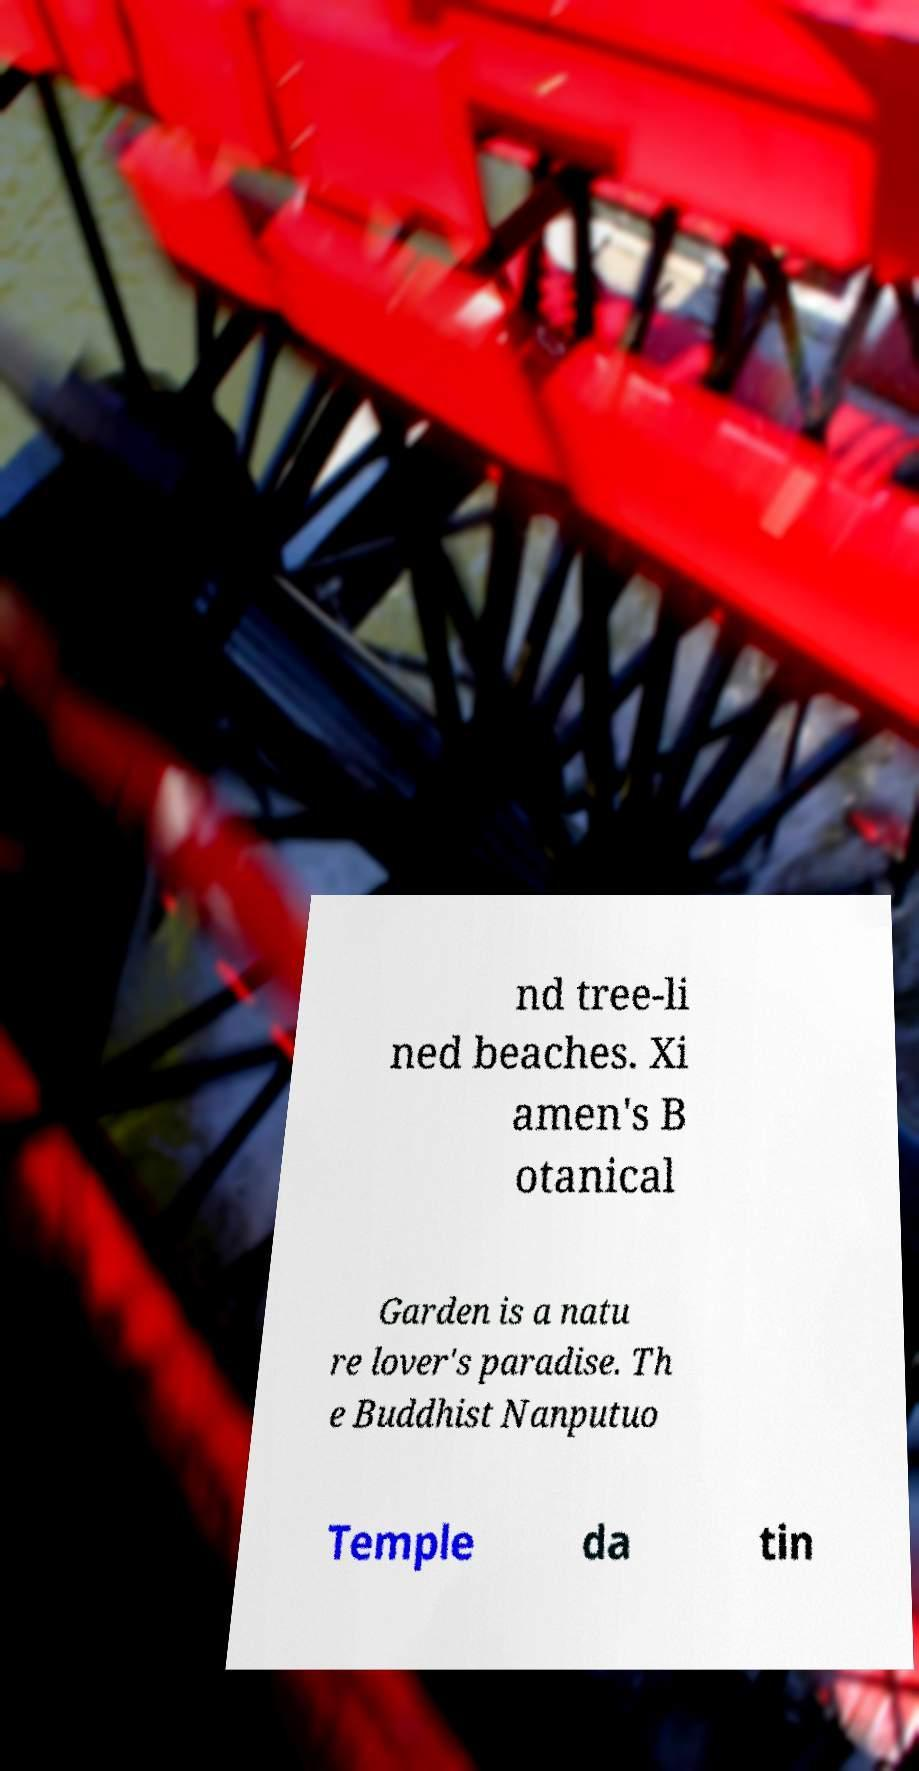Please read and relay the text visible in this image. What does it say? nd tree-li ned beaches. Xi amen's B otanical Garden is a natu re lover's paradise. Th e Buddhist Nanputuo Temple da tin 